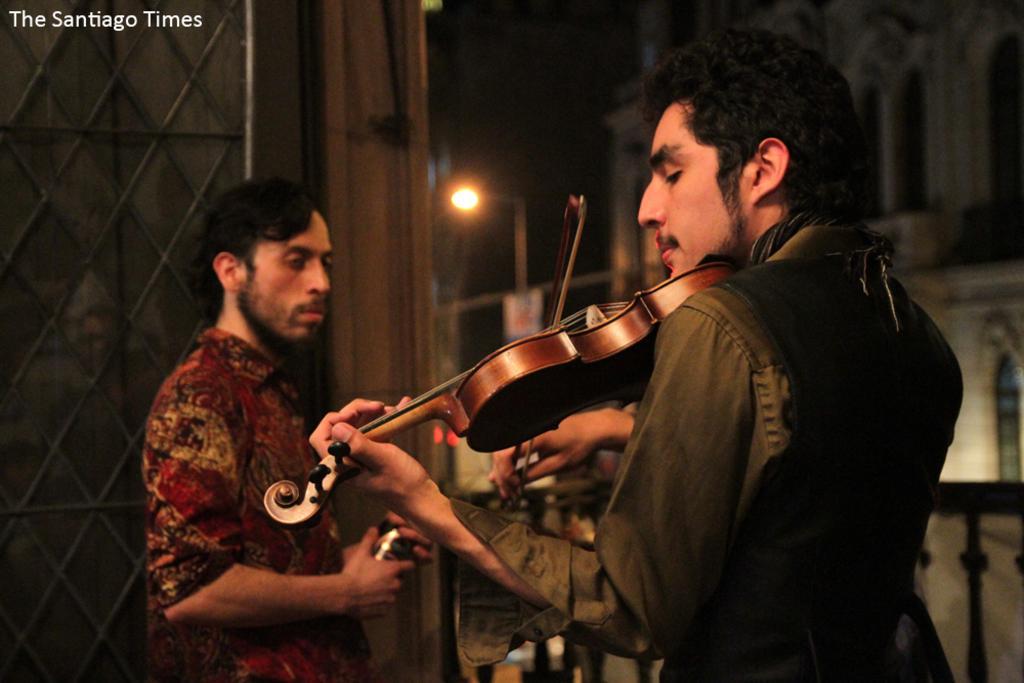In one or two sentences, can you explain what this image depicts? In this image, in the right side there is a boy standing and he is holding a guitar which is in brown color, he is playing the guitar, in the left side there is a boy standing and in the background there is a street light which is in yellow color, there is a wall which is in white color. 